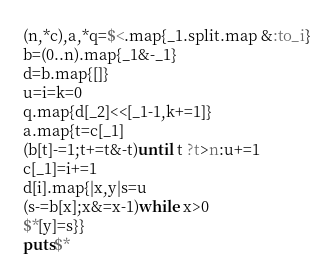Convert code to text. <code><loc_0><loc_0><loc_500><loc_500><_Ruby_>(n,*c),a,*q=$<.map{_1.split.map &:to_i}
b=(0..n).map{_1&-_1}
d=b.map{[]}
u=i=k=0
q.map{d[_2]<<[_1-1,k+=1]}
a.map{t=c[_1]
(b[t]-=1;t+=t&-t)until t ?t>n:u+=1
c[_1]=i+=1
d[i].map{|x,y|s=u
(s-=b[x];x&=x-1)while x>0
$*[y]=s}}
puts$*</code> 